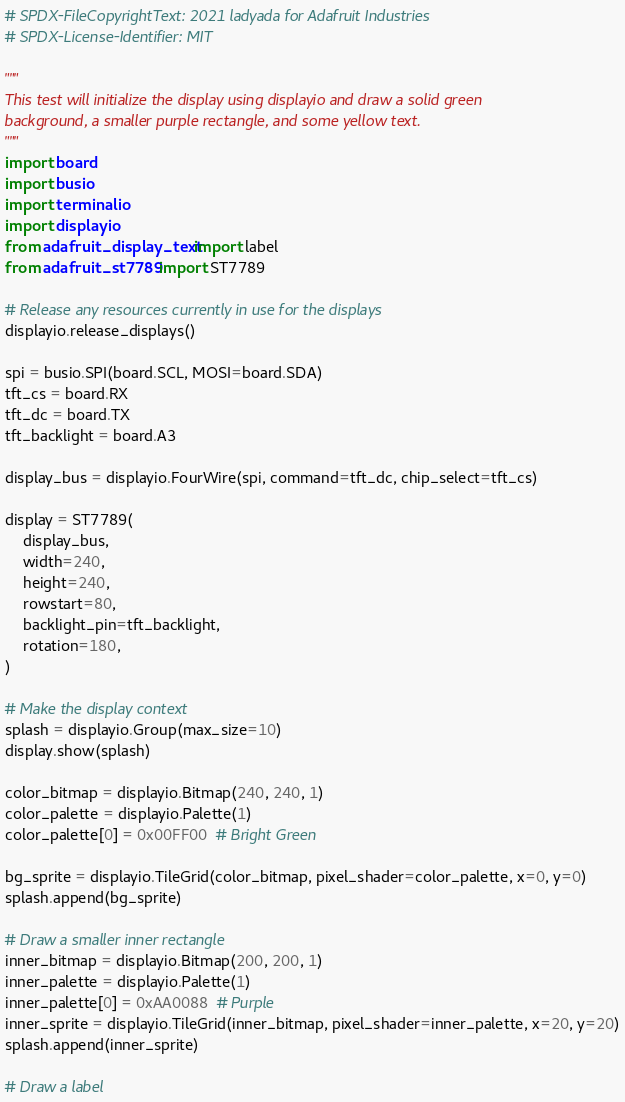Convert code to text. <code><loc_0><loc_0><loc_500><loc_500><_Python_># SPDX-FileCopyrightText: 2021 ladyada for Adafruit Industries
# SPDX-License-Identifier: MIT

"""
This test will initialize the display using displayio and draw a solid green
background, a smaller purple rectangle, and some yellow text.
"""
import board
import busio
import terminalio
import displayio
from adafruit_display_text import label
from adafruit_st7789 import ST7789

# Release any resources currently in use for the displays
displayio.release_displays()

spi = busio.SPI(board.SCL, MOSI=board.SDA)
tft_cs = board.RX
tft_dc = board.TX
tft_backlight = board.A3

display_bus = displayio.FourWire(spi, command=tft_dc, chip_select=tft_cs)

display = ST7789(
    display_bus,
    width=240,
    height=240,
    rowstart=80,
    backlight_pin=tft_backlight,
    rotation=180,
)

# Make the display context
splash = displayio.Group(max_size=10)
display.show(splash)

color_bitmap = displayio.Bitmap(240, 240, 1)
color_palette = displayio.Palette(1)
color_palette[0] = 0x00FF00  # Bright Green

bg_sprite = displayio.TileGrid(color_bitmap, pixel_shader=color_palette, x=0, y=0)
splash.append(bg_sprite)

# Draw a smaller inner rectangle
inner_bitmap = displayio.Bitmap(200, 200, 1)
inner_palette = displayio.Palette(1)
inner_palette[0] = 0xAA0088  # Purple
inner_sprite = displayio.TileGrid(inner_bitmap, pixel_shader=inner_palette, x=20, y=20)
splash.append(inner_sprite)

# Draw a label</code> 